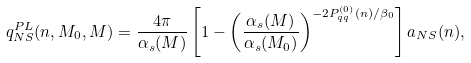<formula> <loc_0><loc_0><loc_500><loc_500>q _ { N S } ^ { P L } ( n , M _ { 0 } , M ) = \frac { 4 \pi } { \alpha _ { s } ( M ) } \left [ 1 - \left ( \frac { \alpha _ { s } ( M ) } { \alpha _ { s } ( M _ { 0 } ) } \right ) ^ { - 2 P ^ { ( 0 ) } _ { q q } ( n ) / \beta _ { 0 } } \right ] a _ { N S } ( n ) ,</formula> 